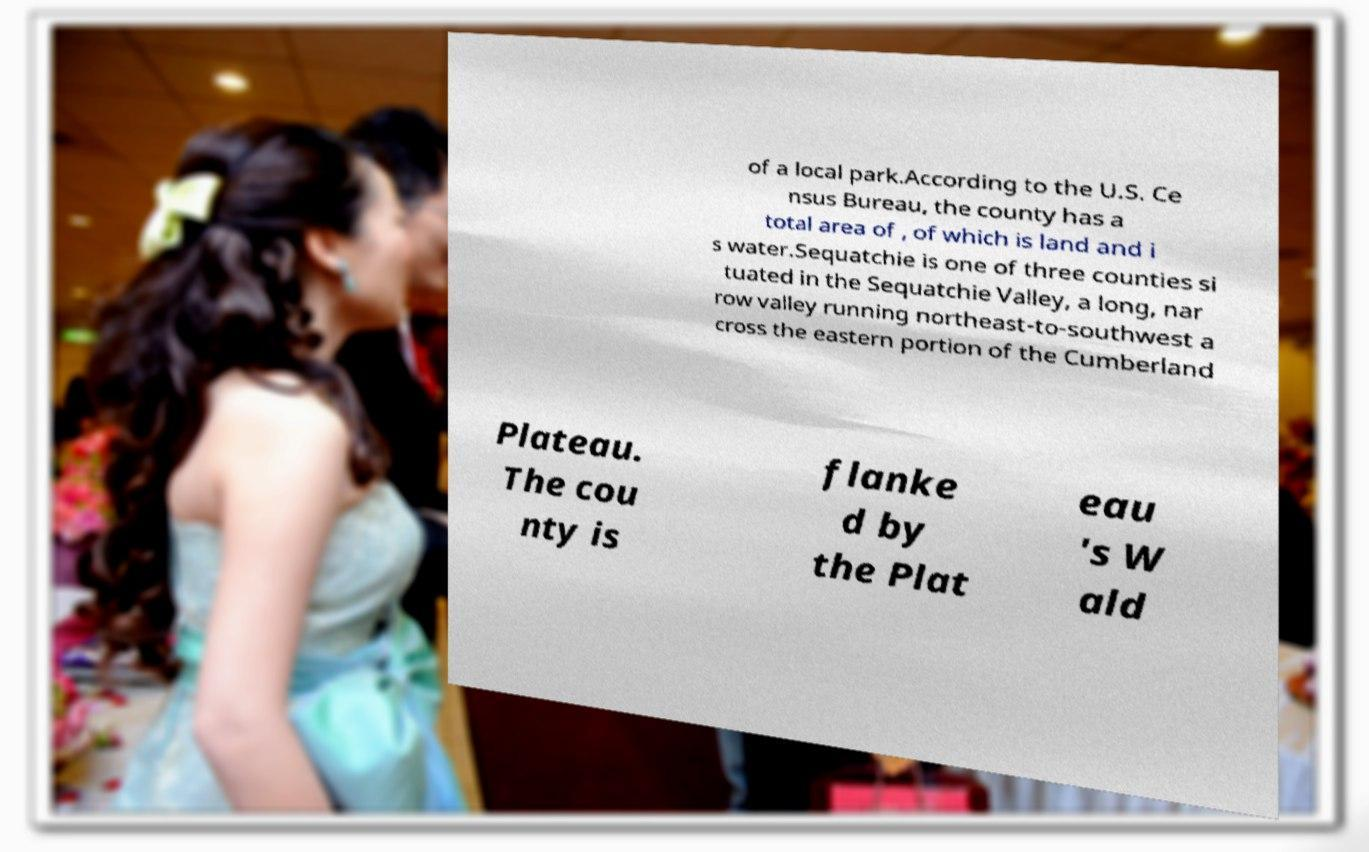Please identify and transcribe the text found in this image. of a local park.According to the U.S. Ce nsus Bureau, the county has a total area of , of which is land and i s water.Sequatchie is one of three counties si tuated in the Sequatchie Valley, a long, nar row valley running northeast-to-southwest a cross the eastern portion of the Cumberland Plateau. The cou nty is flanke d by the Plat eau 's W ald 